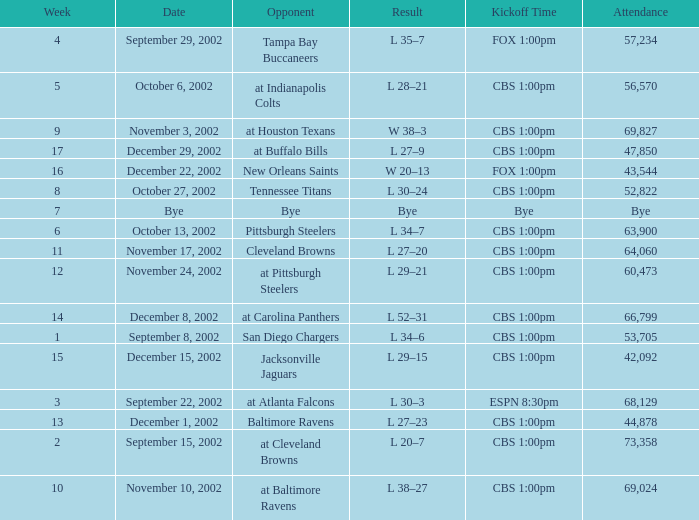How many people attended the game with a kickoff time of cbs 1:00pm, in a week earlier than 8, on September 15, 2002? 73358.0. 